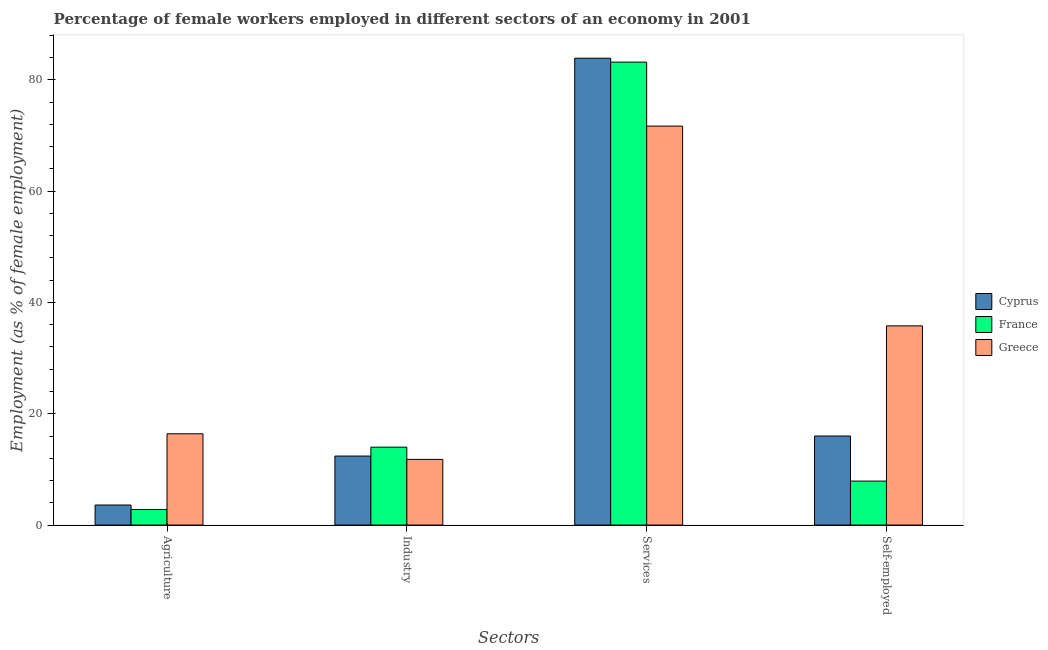How many groups of bars are there?
Offer a terse response. 4. Are the number of bars per tick equal to the number of legend labels?
Ensure brevity in your answer.  Yes. How many bars are there on the 3rd tick from the right?
Your answer should be very brief. 3. What is the label of the 4th group of bars from the left?
Your answer should be very brief. Self-employed. What is the percentage of female workers in industry in France?
Give a very brief answer. 14. Across all countries, what is the maximum percentage of female workers in services?
Your answer should be very brief. 83.9. Across all countries, what is the minimum percentage of female workers in agriculture?
Make the answer very short. 2.8. In which country was the percentage of female workers in services maximum?
Your response must be concise. Cyprus. In which country was the percentage of female workers in industry minimum?
Provide a short and direct response. Greece. What is the total percentage of female workers in services in the graph?
Offer a very short reply. 238.8. What is the difference between the percentage of self employed female workers in Cyprus and that in Greece?
Offer a very short reply. -19.8. What is the difference between the percentage of female workers in industry in Cyprus and the percentage of female workers in services in France?
Your answer should be compact. -70.8. What is the average percentage of female workers in agriculture per country?
Give a very brief answer. 7.6. What is the difference between the percentage of female workers in services and percentage of self employed female workers in France?
Provide a short and direct response. 75.3. In how many countries, is the percentage of female workers in industry greater than 12 %?
Ensure brevity in your answer.  2. What is the ratio of the percentage of female workers in services in France to that in Cyprus?
Ensure brevity in your answer.  0.99. Is the percentage of self employed female workers in Cyprus less than that in Greece?
Provide a succinct answer. Yes. Is the difference between the percentage of self employed female workers in Greece and Cyprus greater than the difference between the percentage of female workers in services in Greece and Cyprus?
Your answer should be compact. Yes. What is the difference between the highest and the second highest percentage of female workers in services?
Make the answer very short. 0.7. What is the difference between the highest and the lowest percentage of self employed female workers?
Provide a succinct answer. 27.9. What does the 2nd bar from the left in Industry represents?
Make the answer very short. France. Is it the case that in every country, the sum of the percentage of female workers in agriculture and percentage of female workers in industry is greater than the percentage of female workers in services?
Keep it short and to the point. No. How many bars are there?
Make the answer very short. 12. How many countries are there in the graph?
Your response must be concise. 3. Are the values on the major ticks of Y-axis written in scientific E-notation?
Provide a succinct answer. No. Does the graph contain any zero values?
Offer a terse response. No. How many legend labels are there?
Provide a succinct answer. 3. What is the title of the graph?
Give a very brief answer. Percentage of female workers employed in different sectors of an economy in 2001. What is the label or title of the X-axis?
Your answer should be very brief. Sectors. What is the label or title of the Y-axis?
Keep it short and to the point. Employment (as % of female employment). What is the Employment (as % of female employment) in Cyprus in Agriculture?
Provide a short and direct response. 3.6. What is the Employment (as % of female employment) of France in Agriculture?
Your answer should be very brief. 2.8. What is the Employment (as % of female employment) of Greece in Agriculture?
Your answer should be compact. 16.4. What is the Employment (as % of female employment) of Cyprus in Industry?
Your response must be concise. 12.4. What is the Employment (as % of female employment) of France in Industry?
Provide a short and direct response. 14. What is the Employment (as % of female employment) of Greece in Industry?
Your response must be concise. 11.8. What is the Employment (as % of female employment) of Cyprus in Services?
Provide a short and direct response. 83.9. What is the Employment (as % of female employment) of France in Services?
Ensure brevity in your answer.  83.2. What is the Employment (as % of female employment) in Greece in Services?
Your response must be concise. 71.7. What is the Employment (as % of female employment) of France in Self-employed?
Your response must be concise. 7.9. What is the Employment (as % of female employment) of Greece in Self-employed?
Make the answer very short. 35.8. Across all Sectors, what is the maximum Employment (as % of female employment) in Cyprus?
Make the answer very short. 83.9. Across all Sectors, what is the maximum Employment (as % of female employment) in France?
Your answer should be compact. 83.2. Across all Sectors, what is the maximum Employment (as % of female employment) of Greece?
Your answer should be compact. 71.7. Across all Sectors, what is the minimum Employment (as % of female employment) of Cyprus?
Offer a terse response. 3.6. Across all Sectors, what is the minimum Employment (as % of female employment) in France?
Offer a terse response. 2.8. Across all Sectors, what is the minimum Employment (as % of female employment) of Greece?
Your answer should be compact. 11.8. What is the total Employment (as % of female employment) in Cyprus in the graph?
Give a very brief answer. 115.9. What is the total Employment (as % of female employment) in France in the graph?
Give a very brief answer. 107.9. What is the total Employment (as % of female employment) in Greece in the graph?
Your response must be concise. 135.7. What is the difference between the Employment (as % of female employment) in Cyprus in Agriculture and that in Industry?
Make the answer very short. -8.8. What is the difference between the Employment (as % of female employment) in France in Agriculture and that in Industry?
Ensure brevity in your answer.  -11.2. What is the difference between the Employment (as % of female employment) of Cyprus in Agriculture and that in Services?
Ensure brevity in your answer.  -80.3. What is the difference between the Employment (as % of female employment) in France in Agriculture and that in Services?
Your response must be concise. -80.4. What is the difference between the Employment (as % of female employment) in Greece in Agriculture and that in Services?
Provide a short and direct response. -55.3. What is the difference between the Employment (as % of female employment) in France in Agriculture and that in Self-employed?
Ensure brevity in your answer.  -5.1. What is the difference between the Employment (as % of female employment) in Greece in Agriculture and that in Self-employed?
Provide a succinct answer. -19.4. What is the difference between the Employment (as % of female employment) of Cyprus in Industry and that in Services?
Your response must be concise. -71.5. What is the difference between the Employment (as % of female employment) of France in Industry and that in Services?
Provide a short and direct response. -69.2. What is the difference between the Employment (as % of female employment) of Greece in Industry and that in Services?
Ensure brevity in your answer.  -59.9. What is the difference between the Employment (as % of female employment) in Cyprus in Industry and that in Self-employed?
Provide a succinct answer. -3.6. What is the difference between the Employment (as % of female employment) of Cyprus in Services and that in Self-employed?
Ensure brevity in your answer.  67.9. What is the difference between the Employment (as % of female employment) in France in Services and that in Self-employed?
Your answer should be compact. 75.3. What is the difference between the Employment (as % of female employment) of Greece in Services and that in Self-employed?
Keep it short and to the point. 35.9. What is the difference between the Employment (as % of female employment) of France in Agriculture and the Employment (as % of female employment) of Greece in Industry?
Offer a terse response. -9. What is the difference between the Employment (as % of female employment) in Cyprus in Agriculture and the Employment (as % of female employment) in France in Services?
Your answer should be compact. -79.6. What is the difference between the Employment (as % of female employment) in Cyprus in Agriculture and the Employment (as % of female employment) in Greece in Services?
Your answer should be compact. -68.1. What is the difference between the Employment (as % of female employment) of France in Agriculture and the Employment (as % of female employment) of Greece in Services?
Offer a terse response. -68.9. What is the difference between the Employment (as % of female employment) in Cyprus in Agriculture and the Employment (as % of female employment) in France in Self-employed?
Your answer should be compact. -4.3. What is the difference between the Employment (as % of female employment) in Cyprus in Agriculture and the Employment (as % of female employment) in Greece in Self-employed?
Your response must be concise. -32.2. What is the difference between the Employment (as % of female employment) in France in Agriculture and the Employment (as % of female employment) in Greece in Self-employed?
Your answer should be compact. -33. What is the difference between the Employment (as % of female employment) in Cyprus in Industry and the Employment (as % of female employment) in France in Services?
Your answer should be compact. -70.8. What is the difference between the Employment (as % of female employment) in Cyprus in Industry and the Employment (as % of female employment) in Greece in Services?
Offer a terse response. -59.3. What is the difference between the Employment (as % of female employment) in France in Industry and the Employment (as % of female employment) in Greece in Services?
Ensure brevity in your answer.  -57.7. What is the difference between the Employment (as % of female employment) in Cyprus in Industry and the Employment (as % of female employment) in Greece in Self-employed?
Your response must be concise. -23.4. What is the difference between the Employment (as % of female employment) of France in Industry and the Employment (as % of female employment) of Greece in Self-employed?
Give a very brief answer. -21.8. What is the difference between the Employment (as % of female employment) in Cyprus in Services and the Employment (as % of female employment) in France in Self-employed?
Offer a terse response. 76. What is the difference between the Employment (as % of female employment) in Cyprus in Services and the Employment (as % of female employment) in Greece in Self-employed?
Provide a succinct answer. 48.1. What is the difference between the Employment (as % of female employment) of France in Services and the Employment (as % of female employment) of Greece in Self-employed?
Keep it short and to the point. 47.4. What is the average Employment (as % of female employment) in Cyprus per Sectors?
Keep it short and to the point. 28.98. What is the average Employment (as % of female employment) of France per Sectors?
Make the answer very short. 26.98. What is the average Employment (as % of female employment) of Greece per Sectors?
Offer a terse response. 33.92. What is the difference between the Employment (as % of female employment) in Cyprus and Employment (as % of female employment) in France in Agriculture?
Your answer should be compact. 0.8. What is the difference between the Employment (as % of female employment) in France and Employment (as % of female employment) in Greece in Industry?
Offer a very short reply. 2.2. What is the difference between the Employment (as % of female employment) of France and Employment (as % of female employment) of Greece in Services?
Your answer should be very brief. 11.5. What is the difference between the Employment (as % of female employment) of Cyprus and Employment (as % of female employment) of Greece in Self-employed?
Give a very brief answer. -19.8. What is the difference between the Employment (as % of female employment) of France and Employment (as % of female employment) of Greece in Self-employed?
Provide a short and direct response. -27.9. What is the ratio of the Employment (as % of female employment) in Cyprus in Agriculture to that in Industry?
Offer a terse response. 0.29. What is the ratio of the Employment (as % of female employment) in France in Agriculture to that in Industry?
Your answer should be compact. 0.2. What is the ratio of the Employment (as % of female employment) of Greece in Agriculture to that in Industry?
Offer a very short reply. 1.39. What is the ratio of the Employment (as % of female employment) in Cyprus in Agriculture to that in Services?
Your response must be concise. 0.04. What is the ratio of the Employment (as % of female employment) in France in Agriculture to that in Services?
Keep it short and to the point. 0.03. What is the ratio of the Employment (as % of female employment) of Greece in Agriculture to that in Services?
Your response must be concise. 0.23. What is the ratio of the Employment (as % of female employment) of Cyprus in Agriculture to that in Self-employed?
Offer a very short reply. 0.23. What is the ratio of the Employment (as % of female employment) of France in Agriculture to that in Self-employed?
Ensure brevity in your answer.  0.35. What is the ratio of the Employment (as % of female employment) in Greece in Agriculture to that in Self-employed?
Give a very brief answer. 0.46. What is the ratio of the Employment (as % of female employment) in Cyprus in Industry to that in Services?
Offer a terse response. 0.15. What is the ratio of the Employment (as % of female employment) in France in Industry to that in Services?
Provide a short and direct response. 0.17. What is the ratio of the Employment (as % of female employment) in Greece in Industry to that in Services?
Keep it short and to the point. 0.16. What is the ratio of the Employment (as % of female employment) of Cyprus in Industry to that in Self-employed?
Your answer should be very brief. 0.78. What is the ratio of the Employment (as % of female employment) of France in Industry to that in Self-employed?
Give a very brief answer. 1.77. What is the ratio of the Employment (as % of female employment) in Greece in Industry to that in Self-employed?
Your answer should be very brief. 0.33. What is the ratio of the Employment (as % of female employment) of Cyprus in Services to that in Self-employed?
Provide a short and direct response. 5.24. What is the ratio of the Employment (as % of female employment) in France in Services to that in Self-employed?
Provide a short and direct response. 10.53. What is the ratio of the Employment (as % of female employment) of Greece in Services to that in Self-employed?
Your answer should be very brief. 2. What is the difference between the highest and the second highest Employment (as % of female employment) of Cyprus?
Keep it short and to the point. 67.9. What is the difference between the highest and the second highest Employment (as % of female employment) of France?
Give a very brief answer. 69.2. What is the difference between the highest and the second highest Employment (as % of female employment) of Greece?
Ensure brevity in your answer.  35.9. What is the difference between the highest and the lowest Employment (as % of female employment) in Cyprus?
Offer a very short reply. 80.3. What is the difference between the highest and the lowest Employment (as % of female employment) of France?
Keep it short and to the point. 80.4. What is the difference between the highest and the lowest Employment (as % of female employment) of Greece?
Your answer should be compact. 59.9. 